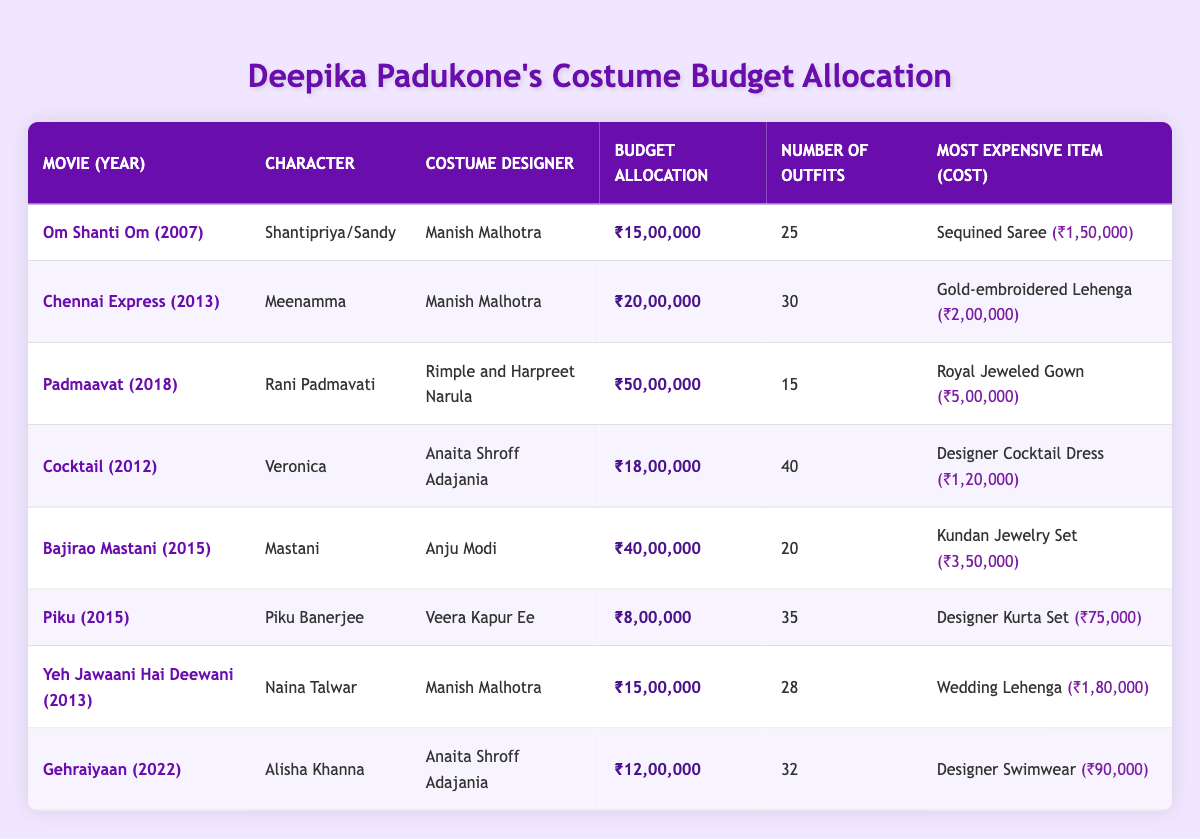What is the budget allocation for the movie "Padmaavat"? The budget allocation for "Padmaavat," as indicated in the table, is ₹50,00,000.
Answer: ₹50,00,000 Which character had the highest budget allocation and what was that amount? "Rani Padmavati" from "Padmaavat" had the highest budget allocation of ₹50,00,000.
Answer: Rani Padmavati; ₹50,00,000 How many outfits were designed for the character "Veronica" in "Cocktail"? The table shows that there were 40 outfits designed for the character "Veronica" in "Cocktail."
Answer: 40 What is the average budget allocation for all movies? By adding the budget allocations (15,00,000 + 20,00,000 + 50,00,000 + 18,00,000 + 40,00,000 + 8,00,000 + 15,00,000 + 12,00,000) which equals ₹1,38,00,000, and dividing by 8 (the number of movies), the average budget allocation is ₹17,25,000.
Answer: ₹17,25,000 Is it true that "Yeh Jawaani Hai Deewani" had a budget allocation of less than ₹20,00,000? Yes, the budget allocation for "Yeh Jawaani Hai Deewani" is ₹15,00,000, which is indeed less than ₹20,00,000.
Answer: Yes What is the total number of outfits across all movies? The total number of outfits can be calculated by summing them up: 25 + 30 + 15 + 40 + 20 + 35 + 28 + 32 =  25+30+15+40+20+35+28+32 = 225 outfits.
Answer: 225 Which costume designer worked on the most movies listed in the table? Manish Malhotra worked on three movies: "Om Shanti Om," "Chennai Express," and "Yeh Jawaani Hai Deewani."
Answer: Manish Malhotra What was the most expensive item in "Bajirao Mastani" and its cost? The most expensive item for "Bajirao Mastani" was the "Kundan Jewelry Set," which cost ₹3,50,000.
Answer: Kundan Jewelry Set; ₹3,50,000 Does "Piku" have more or fewer outfits than "Chennai Express"? "Piku" has 35 outfits while "Chennai Express" has 30 outfits, so "Piku" has more outfits.
Answer: More 